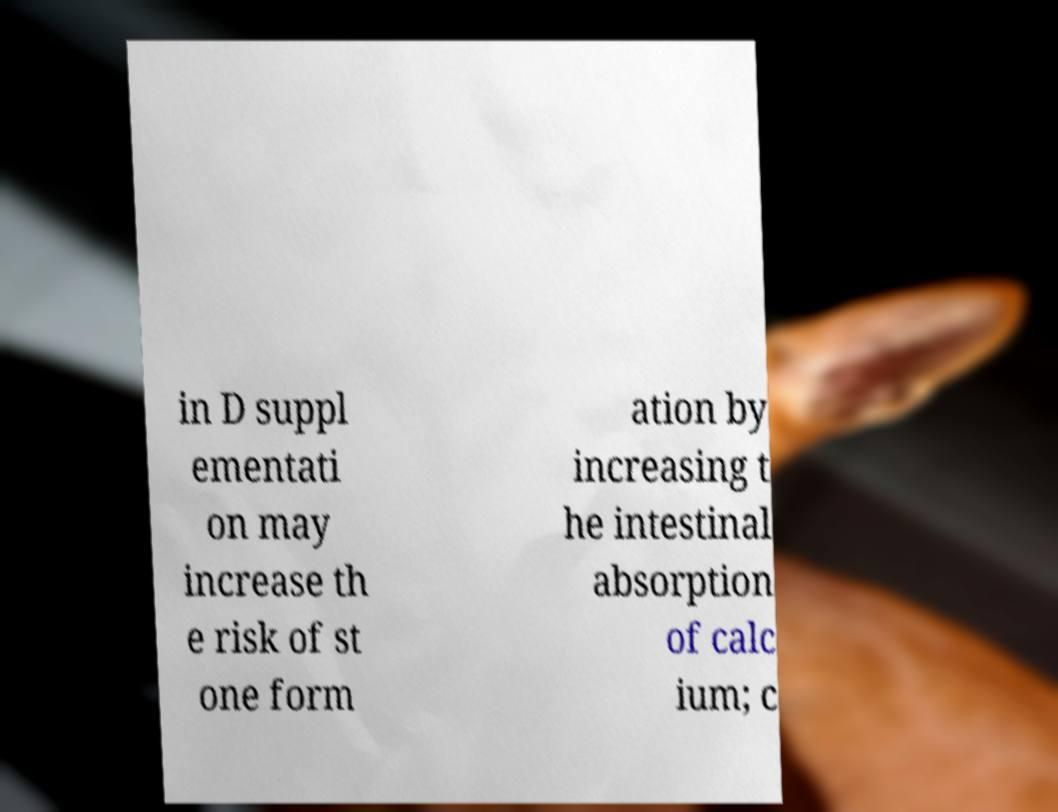For documentation purposes, I need the text within this image transcribed. Could you provide that? in D suppl ementati on may increase th e risk of st one form ation by increasing t he intestinal absorption of calc ium; c 